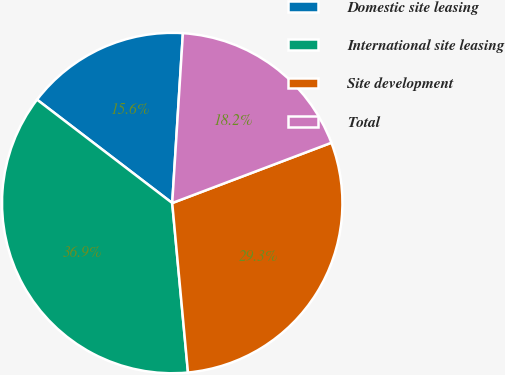Convert chart to OTSL. <chart><loc_0><loc_0><loc_500><loc_500><pie_chart><fcel>Domestic site leasing<fcel>International site leasing<fcel>Site development<fcel>Total<nl><fcel>15.61%<fcel>36.87%<fcel>29.29%<fcel>18.24%<nl></chart> 